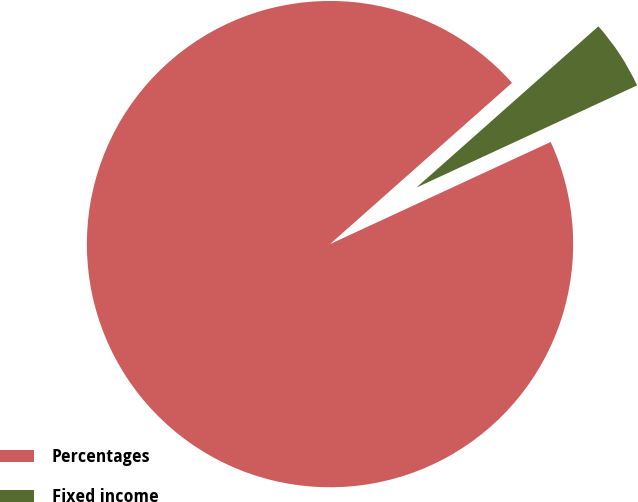<chart> <loc_0><loc_0><loc_500><loc_500><pie_chart><fcel>Percentages<fcel>Fixed income<nl><fcel>95.36%<fcel>4.64%<nl></chart> 